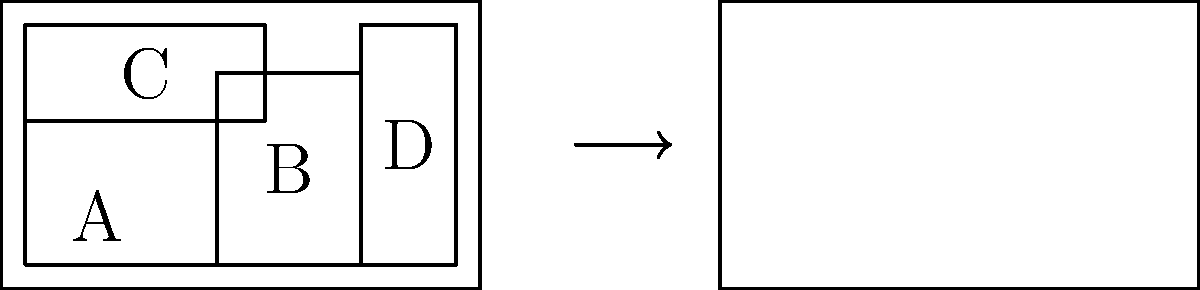As a former concierge, you're tasked with helping a bellhop arrange luggage efficiently. Given the luggage pieces A, B, C, and D, what is the correct order to load them into the empty cart on the right to maximize space usage? Provide your answer as a sequence of letters. To maximize space usage in the bellhop cart, we need to consider the dimensions of each luggage piece and how they can fit together efficiently. Let's analyze each piece:

1. Piece A: 4x3 units
2. Piece B: 3x4 units
3. Piece C: 5x2 units
4. Piece D: 2x5 units

The cart dimensions are 10x6 units. To maximize space usage:

1. Start with piece C (5x2) at the bottom of the cart. This creates a solid base and uses the full width.
2. Place piece A (4x3) next to piece C. This fills the remaining width of the cart (5+4=9 out of 10).
3. Stack piece B (3x4) on top of piece C. This utilizes the vertical space efficiently.
4. Finally, place piece D (2x5) in the remaining vertical space next to piece B.

This arrangement leaves minimal unused space in the cart, ensuring efficient packing.

The correct loading order is: C, A, B, D.
Answer: CABD 